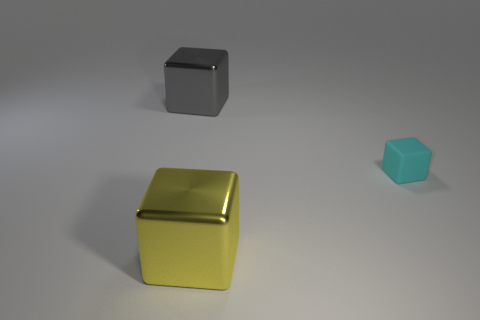How big is the shiny cube that is in front of the big gray metallic cube? The shiny cube appears to be medium-sized relative to the other objects in the image; it's smaller than the big gray cube in the background but larger than the small blue cube. 